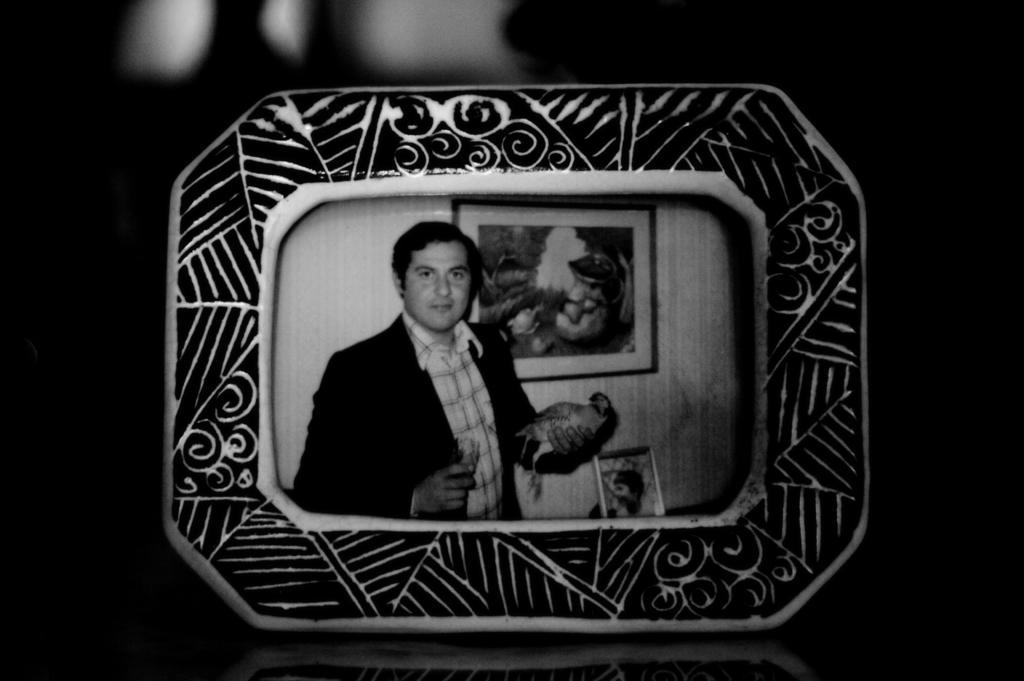Can you describe this image briefly? In this picture I can observe a photo frame. There is a man holding a bird in the photo frame. Behind him there is a photo frame fixed to the wall in this image. The background is completely dark. 